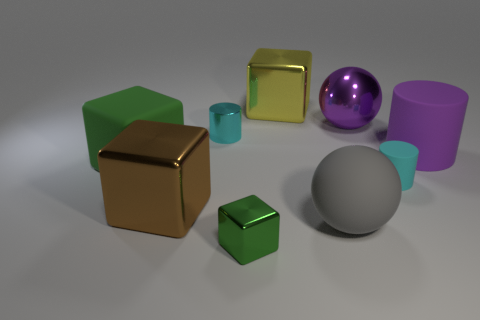There is a sphere that is in front of the large block in front of the cyan cylinder that is to the right of the large yellow thing; what is it made of?
Give a very brief answer. Rubber. What shape is the purple thing that is the same material as the big yellow block?
Keep it short and to the point. Sphere. There is a big purple object left of the cyan matte thing; is there a big gray thing in front of it?
Your answer should be very brief. Yes. What is the size of the purple metallic ball?
Your answer should be very brief. Large. What number of things are big matte cylinders or large brown shiny cylinders?
Ensure brevity in your answer.  1. Are the green thing that is to the left of the big brown block and the cyan thing on the left side of the large yellow metal block made of the same material?
Your answer should be compact. No. There is a large cylinder that is made of the same material as the big gray object; what color is it?
Your answer should be compact. Purple. What number of blue shiny cubes are the same size as the cyan rubber object?
Make the answer very short. 0. What number of other objects are there of the same color as the big cylinder?
Provide a short and direct response. 1. Is there any other thing that is the same size as the metallic sphere?
Provide a succinct answer. Yes. 